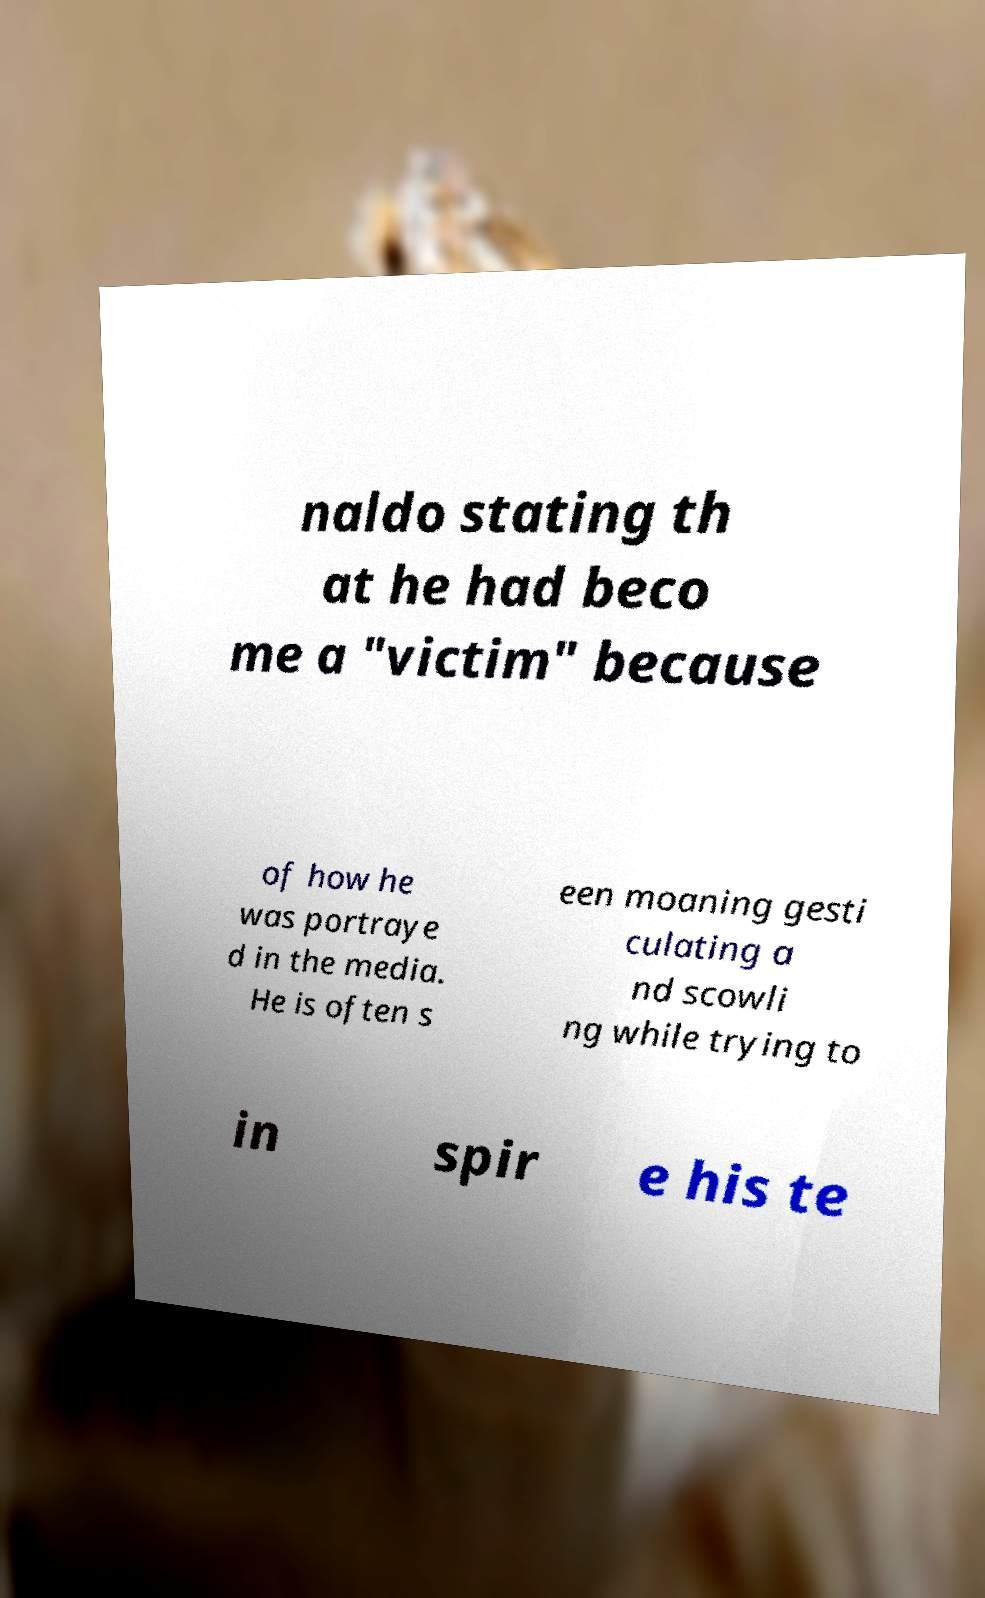Please read and relay the text visible in this image. What does it say? naldo stating th at he had beco me a "victim" because of how he was portraye d in the media. He is often s een moaning gesti culating a nd scowli ng while trying to in spir e his te 